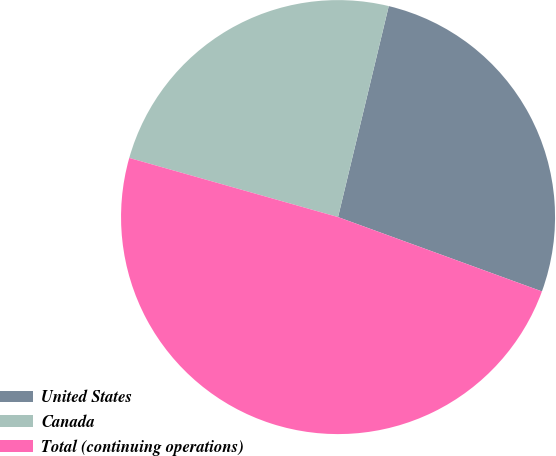Convert chart to OTSL. <chart><loc_0><loc_0><loc_500><loc_500><pie_chart><fcel>United States<fcel>Canada<fcel>Total (continuing operations)<nl><fcel>26.81%<fcel>24.36%<fcel>48.83%<nl></chart> 